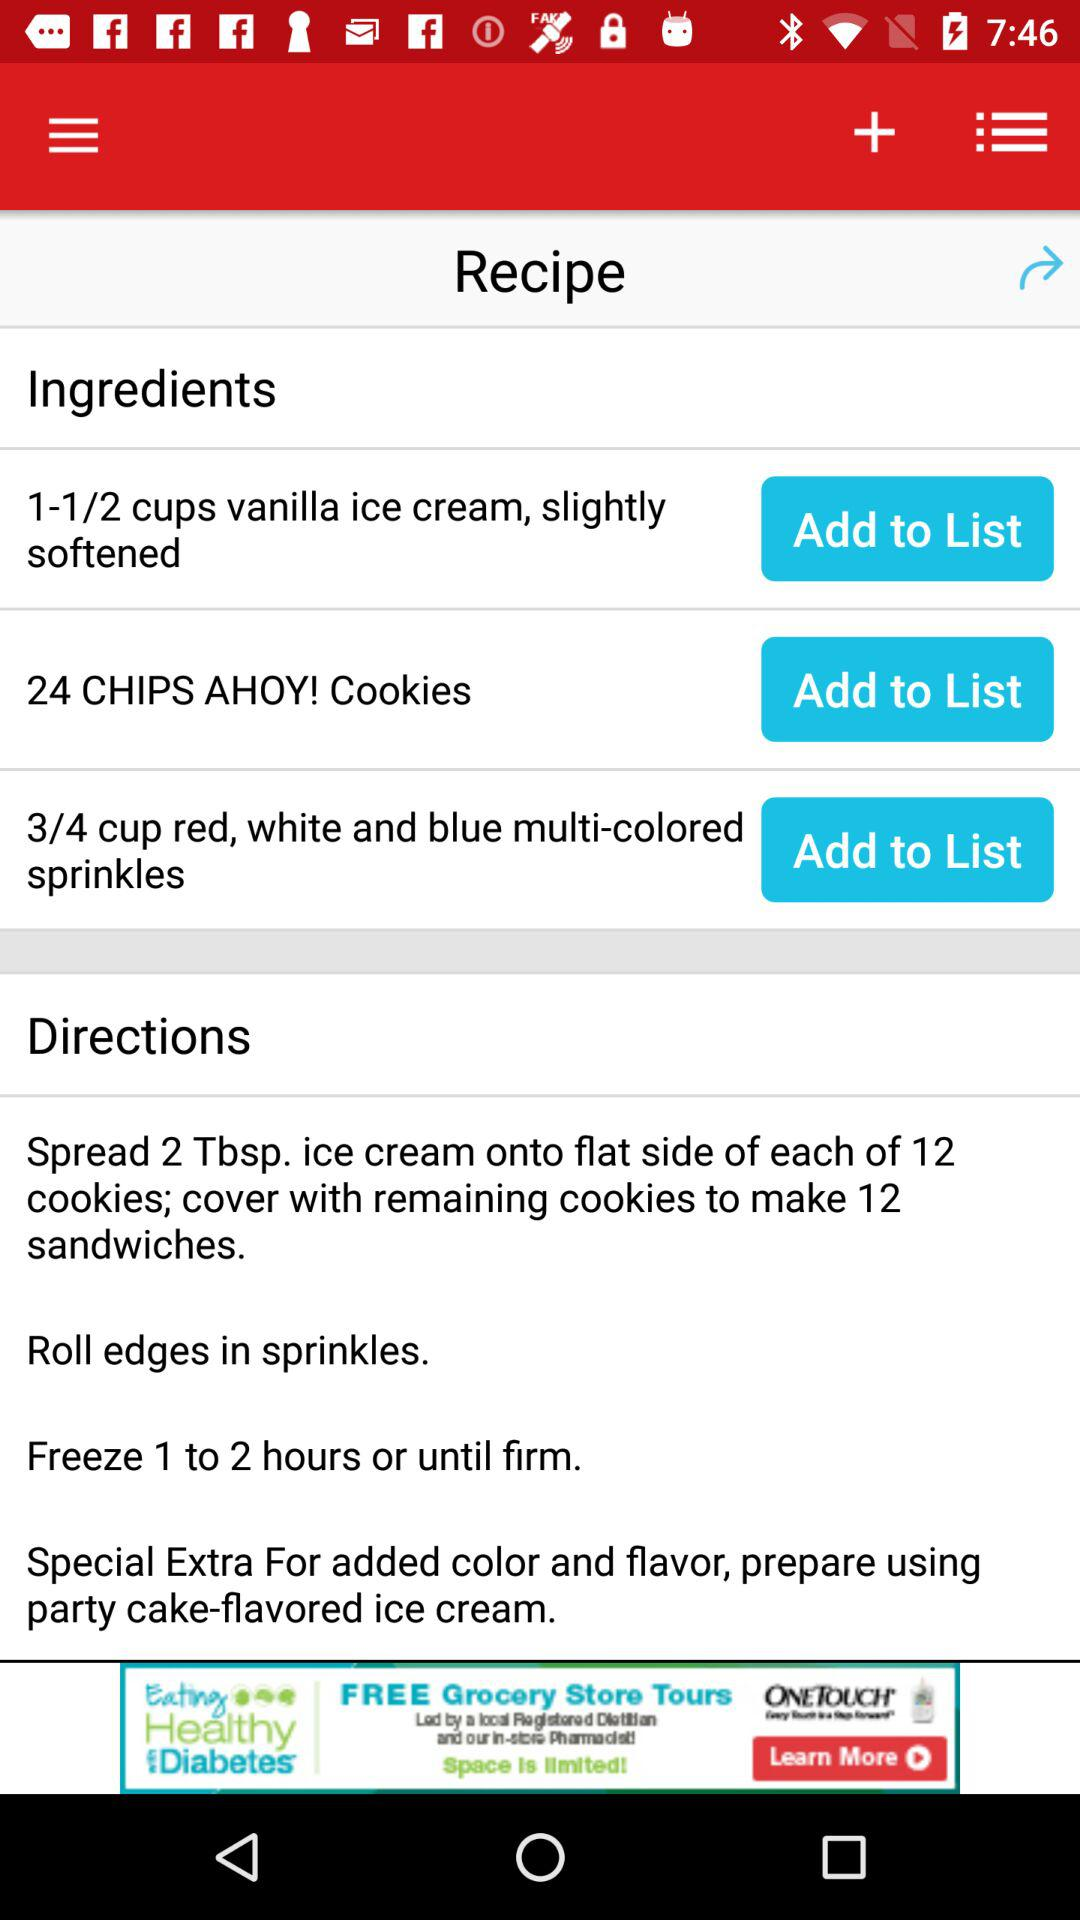How many more cookies are needed than cups of ice cream?
Answer the question using a single word or phrase. 12 